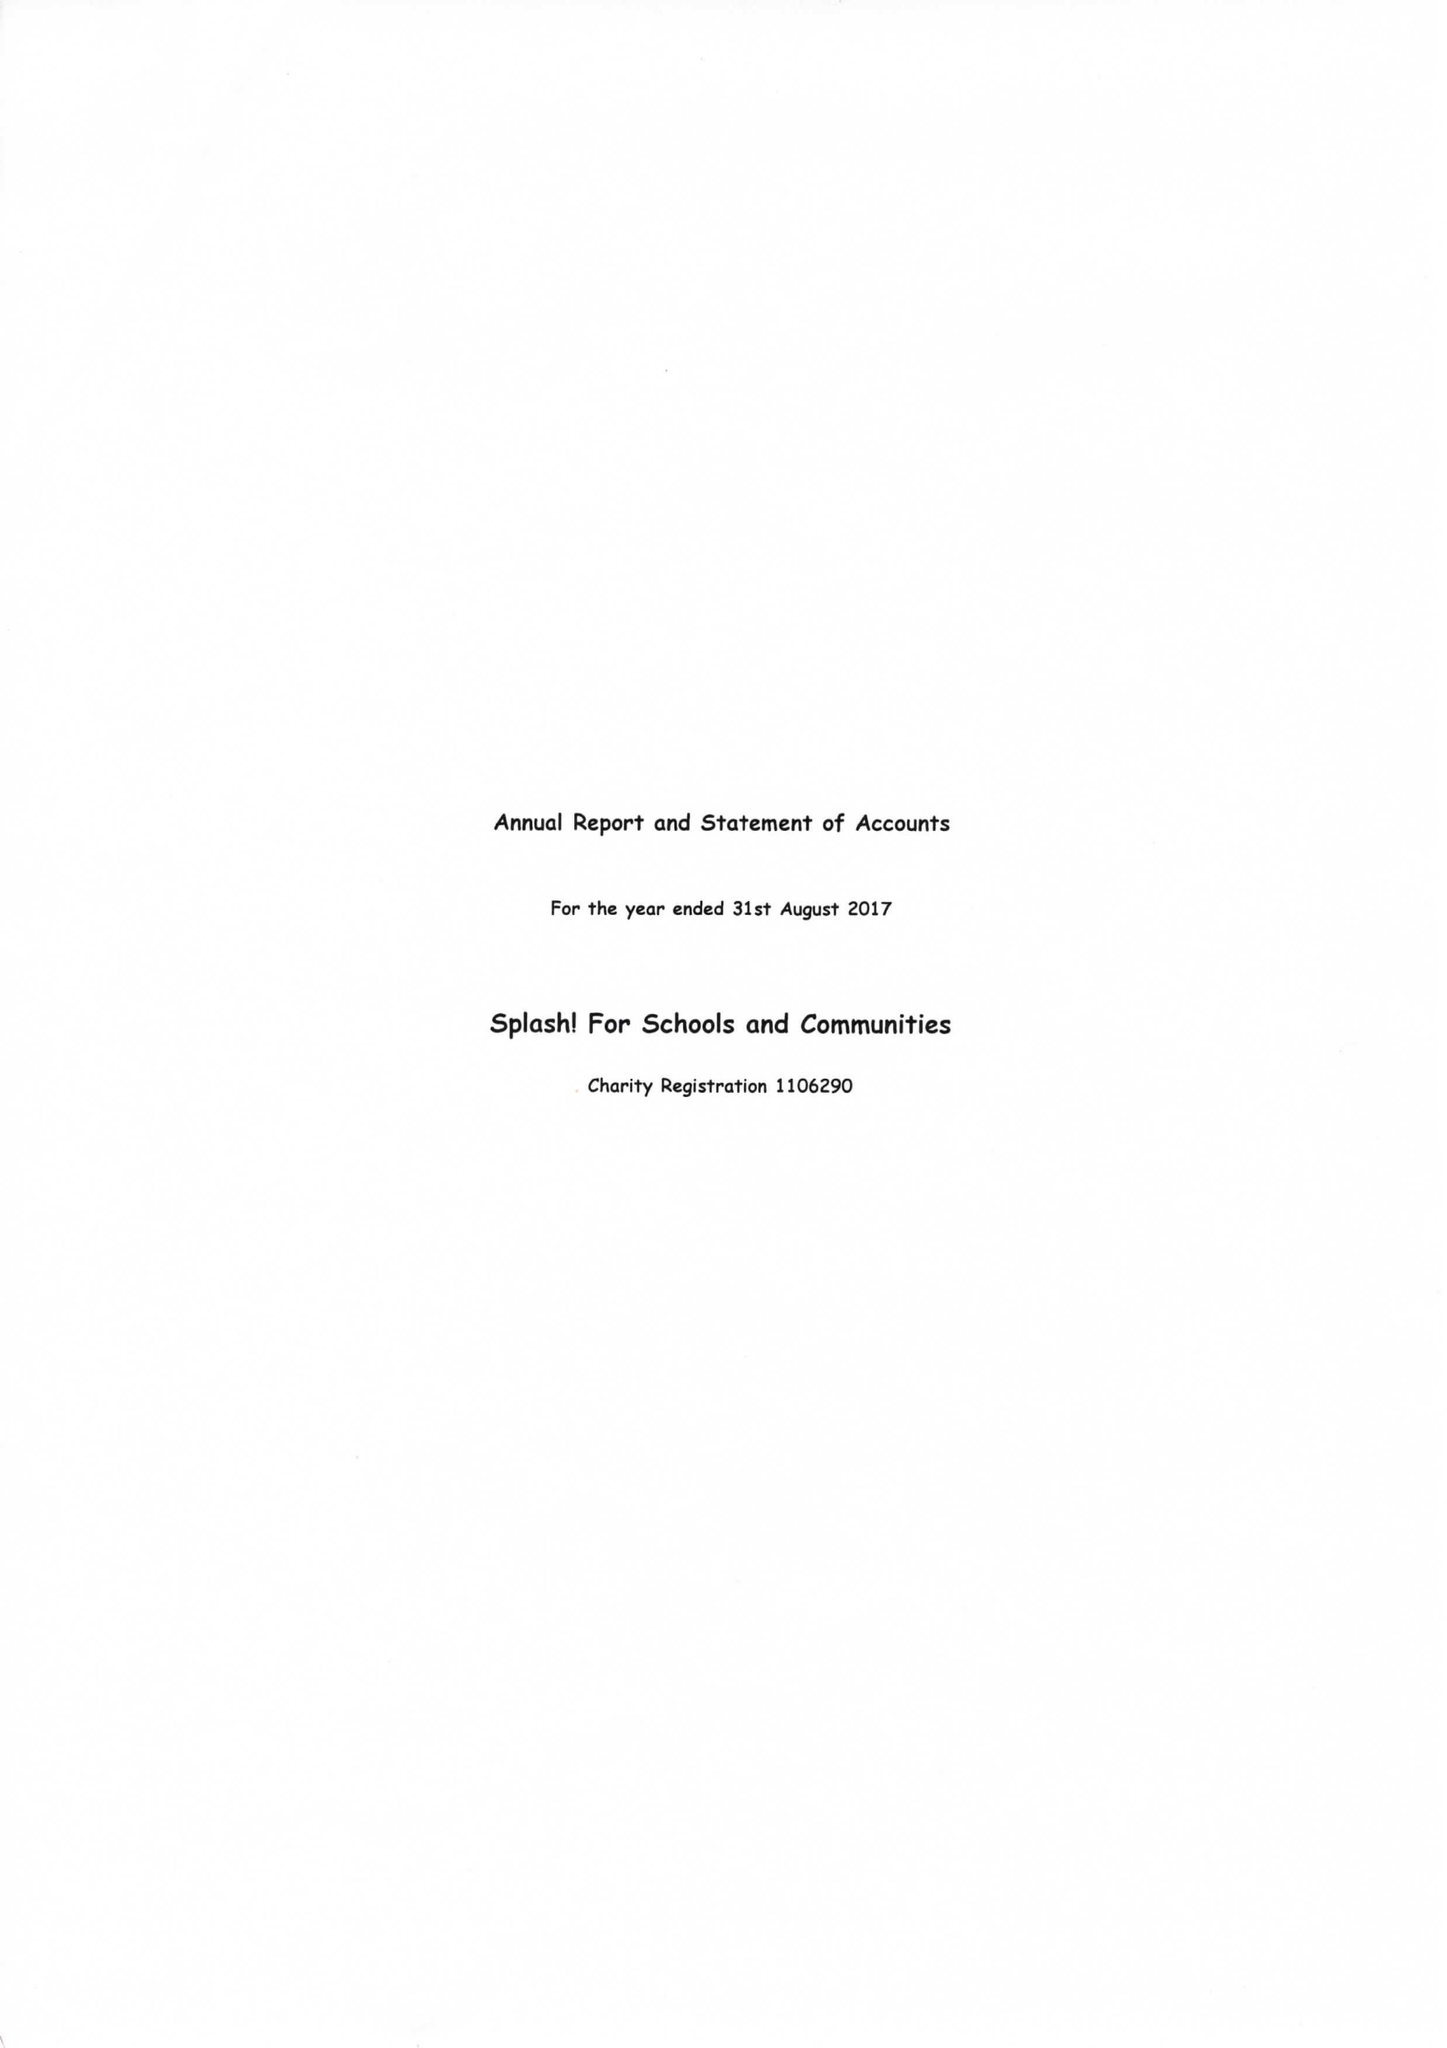What is the value for the spending_annually_in_british_pounds?
Answer the question using a single word or phrase. 49509.00 